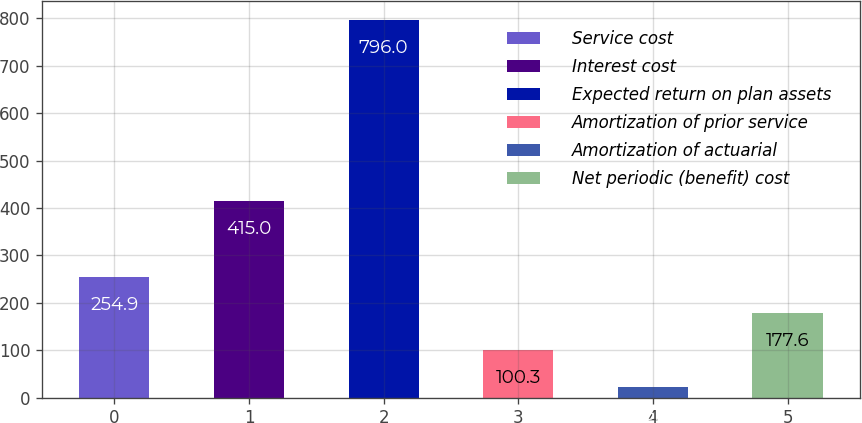<chart> <loc_0><loc_0><loc_500><loc_500><bar_chart><fcel>Service cost<fcel>Interest cost<fcel>Expected return on plan assets<fcel>Amortization of prior service<fcel>Amortization of actuarial<fcel>Net periodic (benefit) cost<nl><fcel>254.9<fcel>415<fcel>796<fcel>100.3<fcel>23<fcel>177.6<nl></chart> 